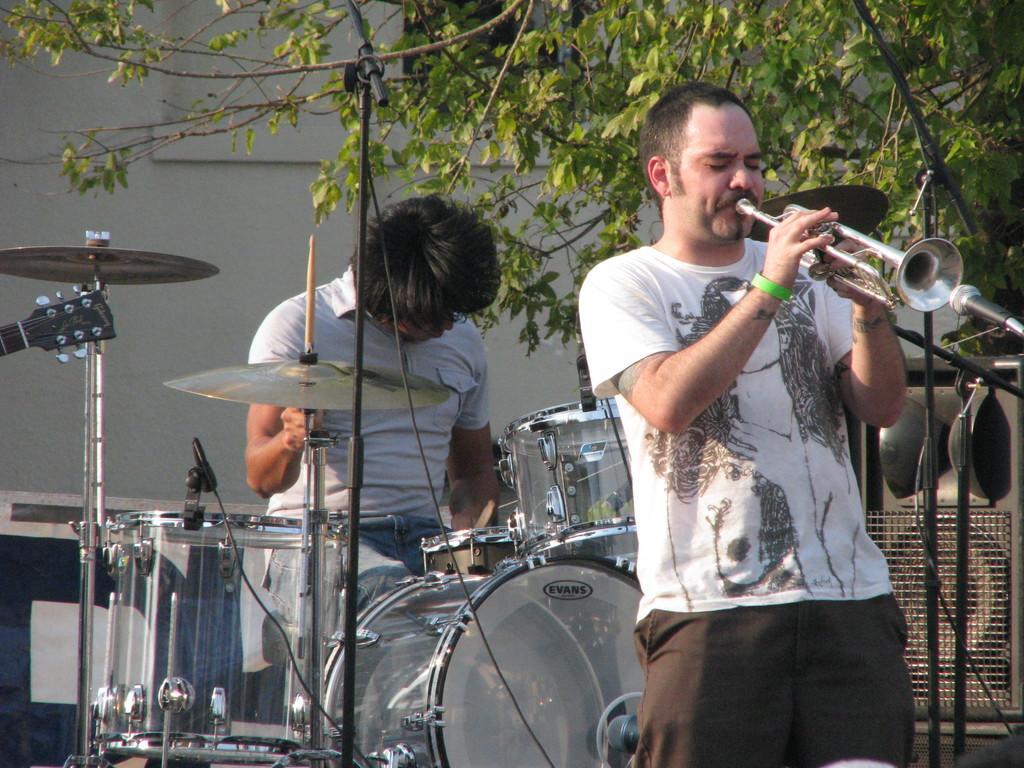Can you describe this image briefly? In this image we can see a man standing holding a trumpet and the other is sitting on a stool holding the sticks. We can also see some musical instruments, a metal grill, a tree and a wall. 